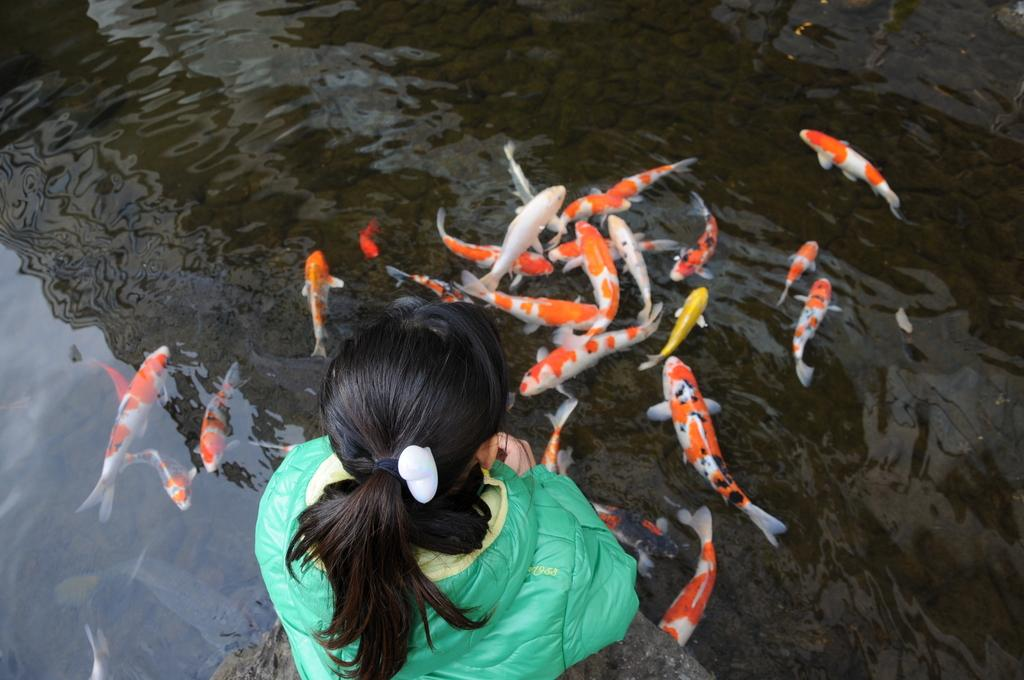Who is the main subject in the picture? There is a woman in the picture. What is the woman doing in the image? The woman is sitting on a rock. Where is the rock located in relation to the water? The rock is in front of the water. What can be seen in the water? There are fishes in the water. What type of muscle is the woman exercising in the image? There is no indication in the image that the woman is exercising or focusing on a specific muscle group. 